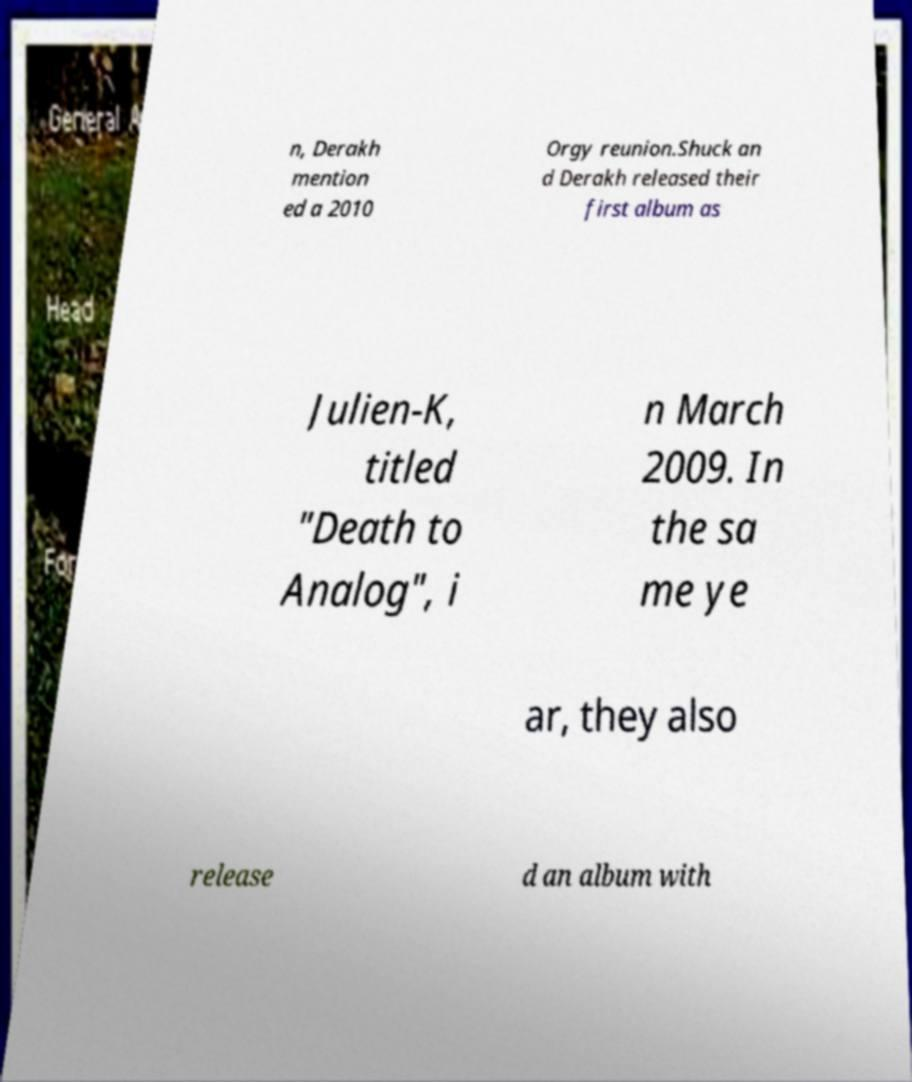Could you extract and type out the text from this image? n, Derakh mention ed a 2010 Orgy reunion.Shuck an d Derakh released their first album as Julien-K, titled "Death to Analog", i n March 2009. In the sa me ye ar, they also release d an album with 